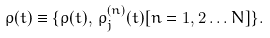<formula> <loc_0><loc_0><loc_500><loc_500>\rho ( t ) \equiv \{ \rho ( t ) , \, \rho _ { j } ^ { ( n ) } ( t ) [ n = 1 , 2 \dots N ] \} .</formula> 